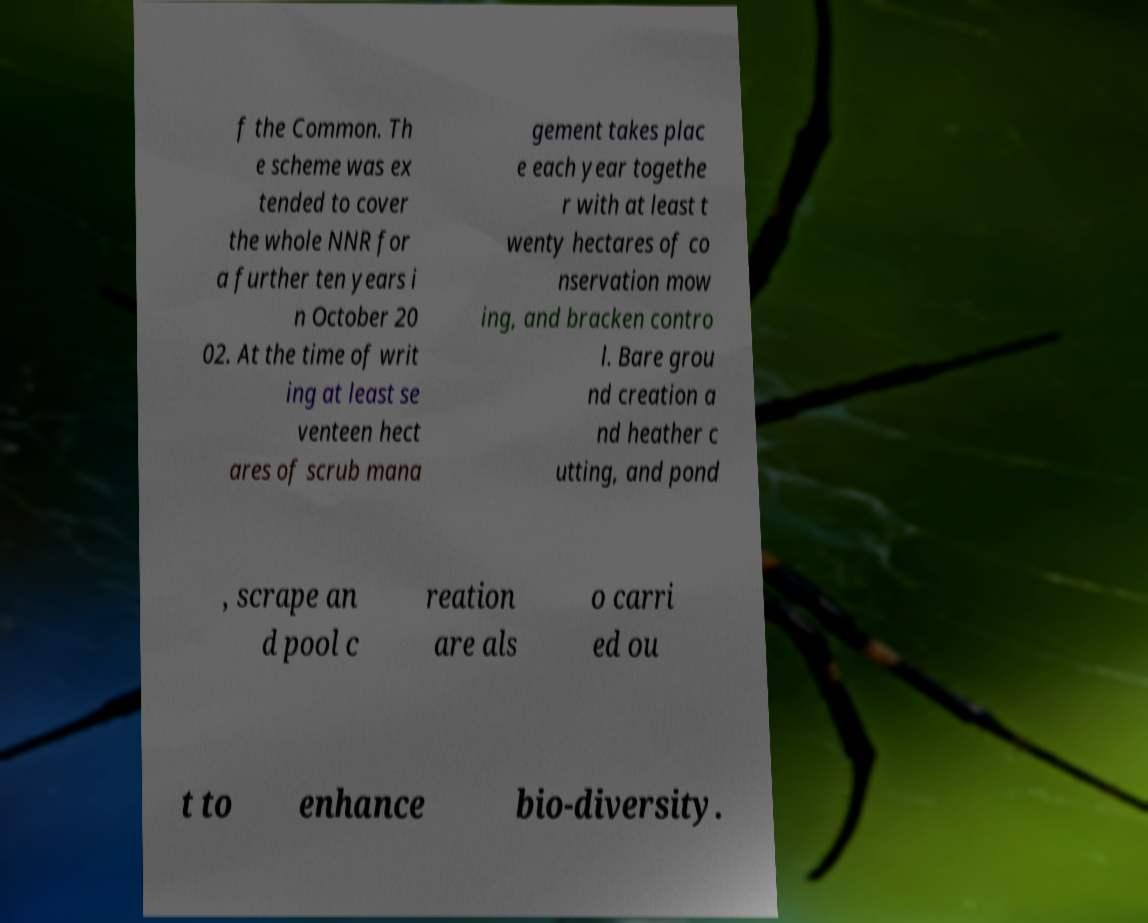Could you assist in decoding the text presented in this image and type it out clearly? f the Common. Th e scheme was ex tended to cover the whole NNR for a further ten years i n October 20 02. At the time of writ ing at least se venteen hect ares of scrub mana gement takes plac e each year togethe r with at least t wenty hectares of co nservation mow ing, and bracken contro l. Bare grou nd creation a nd heather c utting, and pond , scrape an d pool c reation are als o carri ed ou t to enhance bio-diversity. 